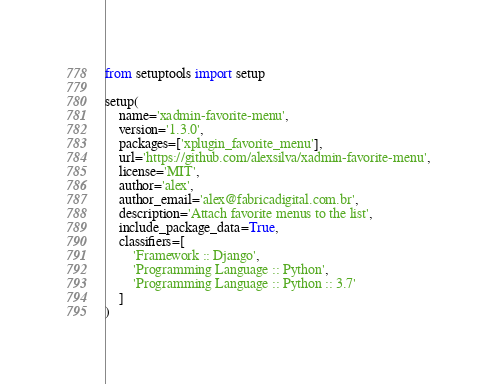<code> <loc_0><loc_0><loc_500><loc_500><_Python_>from setuptools import setup

setup(
    name='xadmin-favorite-menu',
    version='1.3.0',
    packages=['xplugin_favorite_menu'],
    url='https://github.com/alexsilva/xadmin-favorite-menu',
    license='MIT',
    author='alex',
    author_email='alex@fabricadigital.com.br',
    description='Attach favorite menus to the list',
    include_package_data=True,
    classifiers=[
        'Framework :: Django',
        'Programming Language :: Python',
        'Programming Language :: Python :: 3.7'
    ]
)
</code> 